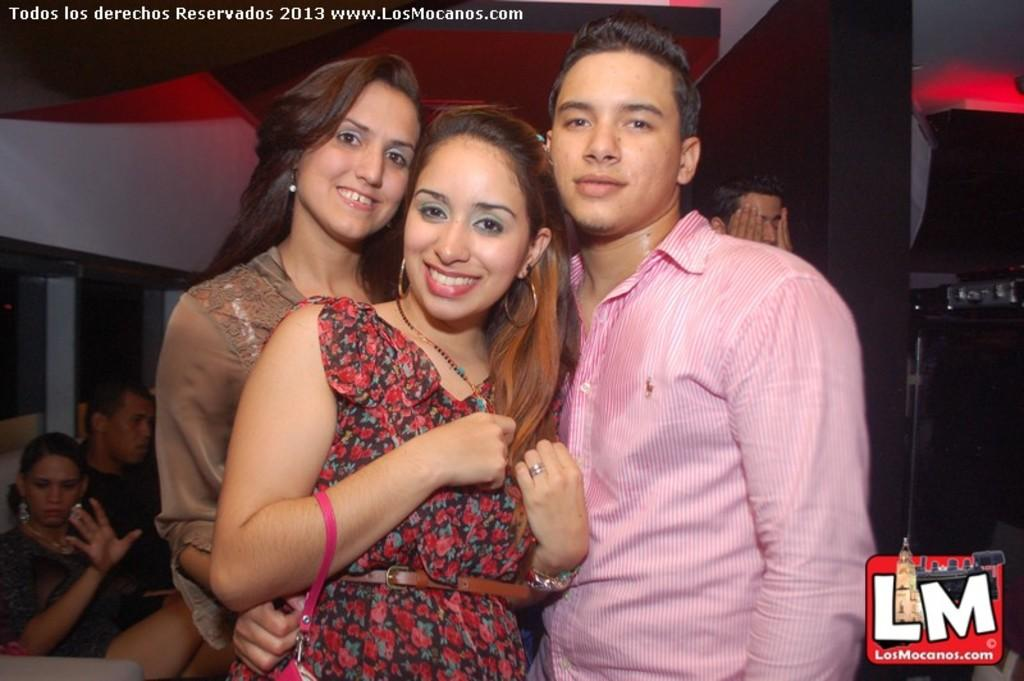How many people are visible in the image? There are three people standing in the image. What else can be seen in the background of the image? There is a group of people, a wall, and a speaker in the background of the image. Are there any watermarks present in the image? Yes, the image has watermarks. What type of beef is being offered at the cemetery in the image? There is no cemetery or beef present in the image. 